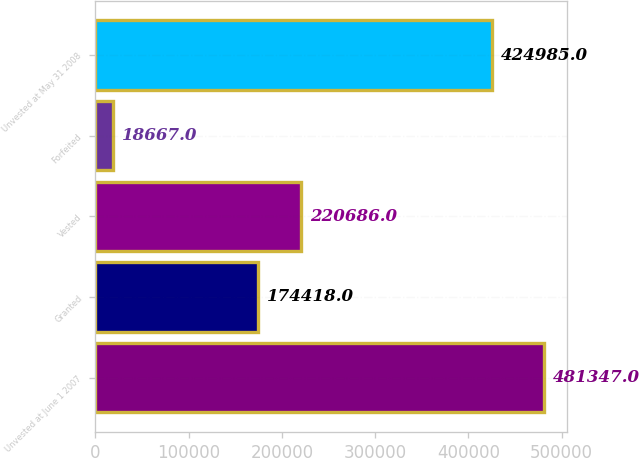<chart> <loc_0><loc_0><loc_500><loc_500><bar_chart><fcel>Unvested at June 1 2007<fcel>Granted<fcel>Vested<fcel>Forfeited<fcel>Unvested at May 31 2008<nl><fcel>481347<fcel>174418<fcel>220686<fcel>18667<fcel>424985<nl></chart> 